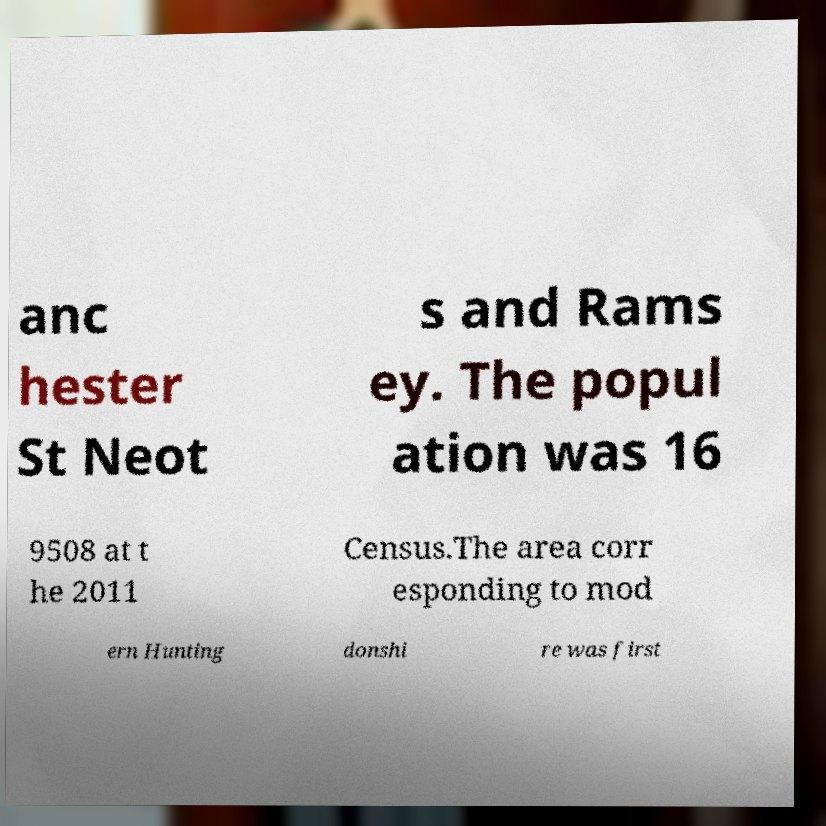There's text embedded in this image that I need extracted. Can you transcribe it verbatim? anc hester St Neot s and Rams ey. The popul ation was 16 9508 at t he 2011 Census.The area corr esponding to mod ern Hunting donshi re was first 